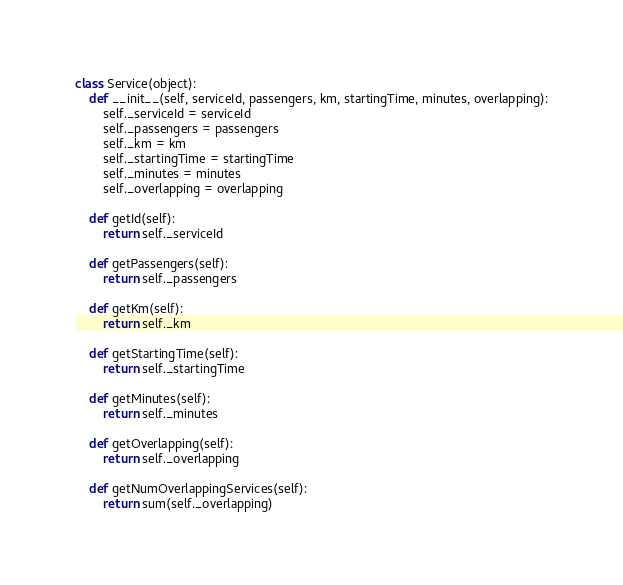Convert code to text. <code><loc_0><loc_0><loc_500><loc_500><_Python_>class Service(object):
    def __init__(self, serviceId, passengers, km, startingTime, minutes, overlapping):
        self._serviceId = serviceId
        self._passengers = passengers
        self._km = km
        self._startingTime = startingTime
        self._minutes = minutes
        self._overlapping = overlapping

    def getId(self):
        return self._serviceId

    def getPassengers(self):
        return self._passengers

    def getKm(self):
        return self._km

    def getStartingTime(self):
        return self._startingTime

    def getMinutes(self):
        return self._minutes

    def getOverlapping(self):
        return self._overlapping

    def getNumOverlappingServices(self):
        return sum(self._overlapping)

</code> 